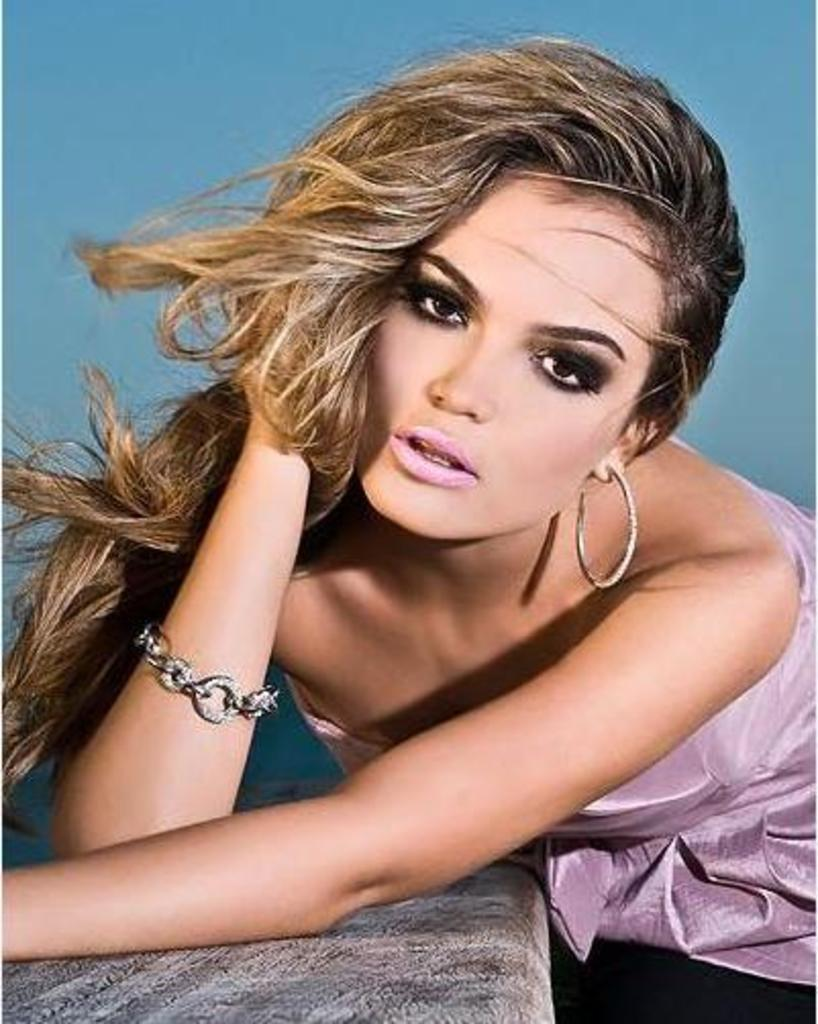Who or what is present in the image? There is a person in the image. What is the person wearing? The person is wearing a pink dress. Can you describe the object in the image? Unfortunately, the provided facts do not mention any specific details about the object in the image. What is the color of the background in the image? The background of the image is blue in color. What type of root can be seen growing in the image? There is no root present in the image. What kind of work is the person doing in the image? The provided facts do not mention any specific activity or work being done by the person in the image. 